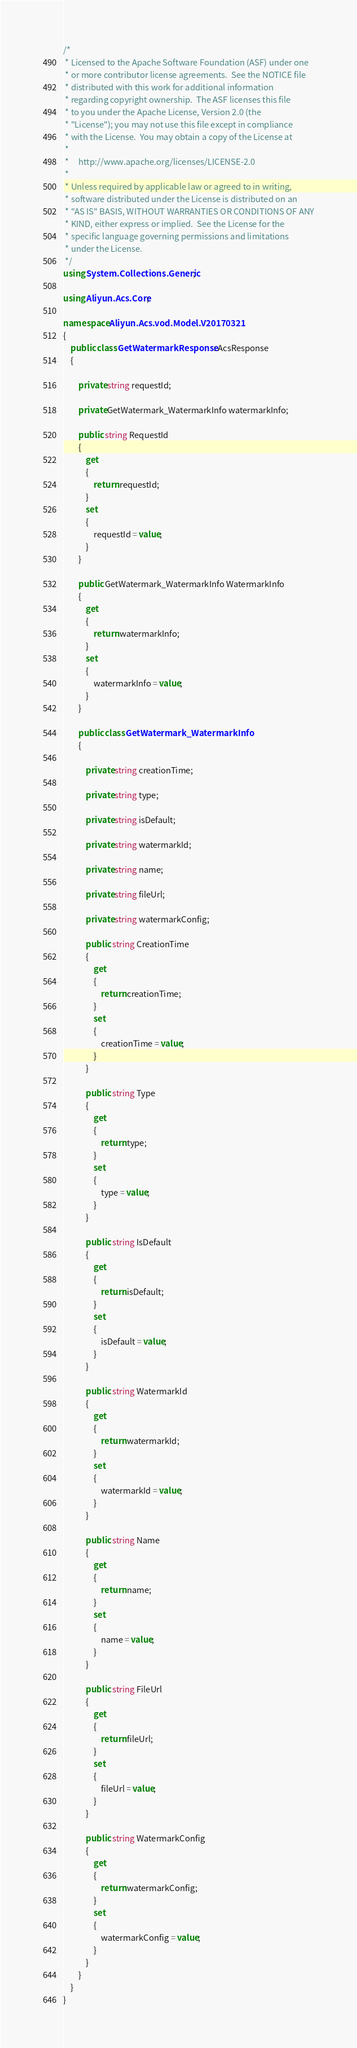<code> <loc_0><loc_0><loc_500><loc_500><_C#_>/*
 * Licensed to the Apache Software Foundation (ASF) under one
 * or more contributor license agreements.  See the NOTICE file
 * distributed with this work for additional information
 * regarding copyright ownership.  The ASF licenses this file
 * to you under the Apache License, Version 2.0 (the
 * "License"); you may not use this file except in compliance
 * with the License.  You may obtain a copy of the License at
 *
 *     http://www.apache.org/licenses/LICENSE-2.0
 *
 * Unless required by applicable law or agreed to in writing,
 * software distributed under the License is distributed on an
 * "AS IS" BASIS, WITHOUT WARRANTIES OR CONDITIONS OF ANY
 * KIND, either express or implied.  See the License for the
 * specific language governing permissions and limitations
 * under the License.
 */
using System.Collections.Generic;

using Aliyun.Acs.Core;

namespace Aliyun.Acs.vod.Model.V20170321
{
	public class GetWatermarkResponse : AcsResponse
	{

		private string requestId;

		private GetWatermark_WatermarkInfo watermarkInfo;

		public string RequestId
		{
			get
			{
				return requestId;
			}
			set	
			{
				requestId = value;
			}
		}

		public GetWatermark_WatermarkInfo WatermarkInfo
		{
			get
			{
				return watermarkInfo;
			}
			set	
			{
				watermarkInfo = value;
			}
		}

		public class GetWatermark_WatermarkInfo
		{

			private string creationTime;

			private string type;

			private string isDefault;

			private string watermarkId;

			private string name;

			private string fileUrl;

			private string watermarkConfig;

			public string CreationTime
			{
				get
				{
					return creationTime;
				}
				set	
				{
					creationTime = value;
				}
			}

			public string Type
			{
				get
				{
					return type;
				}
				set	
				{
					type = value;
				}
			}

			public string IsDefault
			{
				get
				{
					return isDefault;
				}
				set	
				{
					isDefault = value;
				}
			}

			public string WatermarkId
			{
				get
				{
					return watermarkId;
				}
				set	
				{
					watermarkId = value;
				}
			}

			public string Name
			{
				get
				{
					return name;
				}
				set	
				{
					name = value;
				}
			}

			public string FileUrl
			{
				get
				{
					return fileUrl;
				}
				set	
				{
					fileUrl = value;
				}
			}

			public string WatermarkConfig
			{
				get
				{
					return watermarkConfig;
				}
				set	
				{
					watermarkConfig = value;
				}
			}
		}
	}
}
</code> 